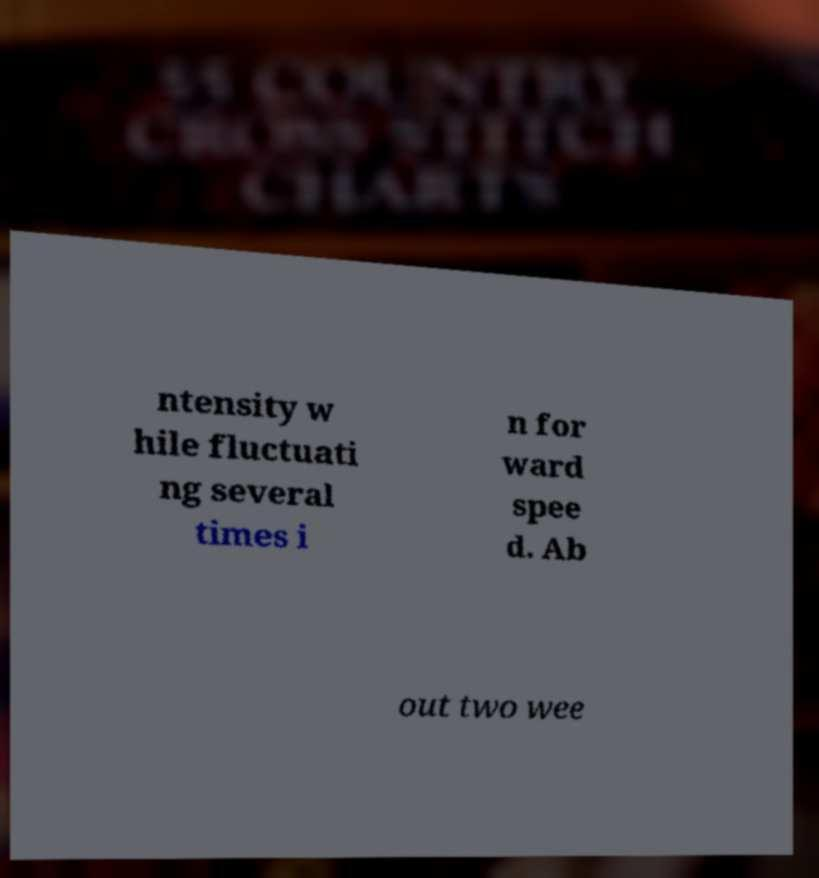For documentation purposes, I need the text within this image transcribed. Could you provide that? ntensity w hile fluctuati ng several times i n for ward spee d. Ab out two wee 